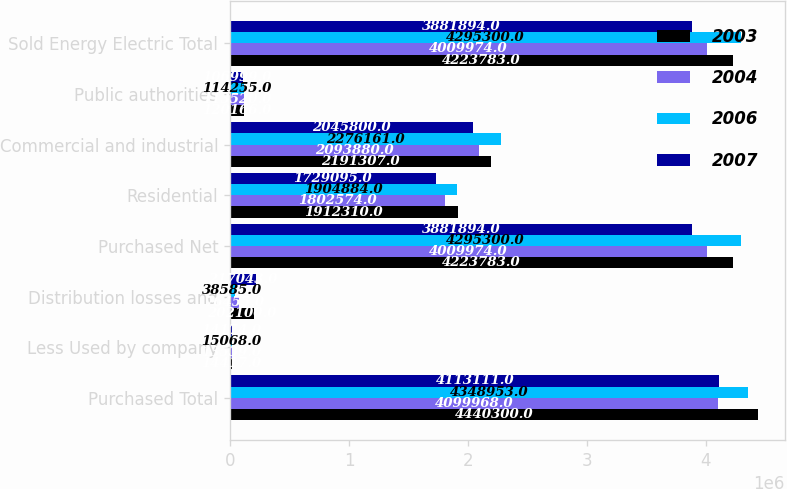Convert chart to OTSL. <chart><loc_0><loc_0><loc_500><loc_500><stacked_bar_chart><ecel><fcel>Purchased Total<fcel>Less Used by company<fcel>Distribution losses and<fcel>Purchased Net<fcel>Residential<fcel>Commercial and industrial<fcel>Public authorities<fcel>Sold Energy Electric Total<nl><fcel>2003<fcel>4.4403e+06<fcel>14417<fcel>202100<fcel>4.22378e+06<fcel>1.91231e+06<fcel>2.19131e+06<fcel>120166<fcel>4.22378e+06<nl><fcel>2004<fcel>4.09997e+06<fcel>13539<fcel>76455<fcel>4.00997e+06<fcel>1.80257e+06<fcel>2.09388e+06<fcel>113520<fcel>4.00997e+06<nl><fcel>2006<fcel>4.34895e+06<fcel>15068<fcel>38585<fcel>4.2953e+06<fcel>1.90488e+06<fcel>2.27616e+06<fcel>114255<fcel>4.2953e+06<nl><fcel>2007<fcel>4.11311e+06<fcel>14174<fcel>217043<fcel>3.88189e+06<fcel>1.7291e+06<fcel>2.0458e+06<fcel>106999<fcel>3.88189e+06<nl></chart> 